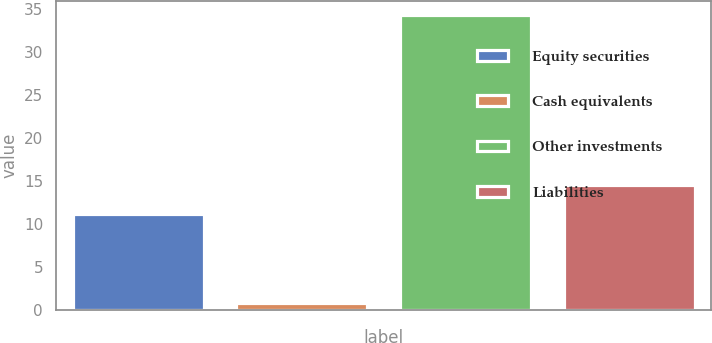Convert chart. <chart><loc_0><loc_0><loc_500><loc_500><bar_chart><fcel>Equity securities<fcel>Cash equivalents<fcel>Other investments<fcel>Liabilities<nl><fcel>11.2<fcel>0.8<fcel>34.3<fcel>14.55<nl></chart> 